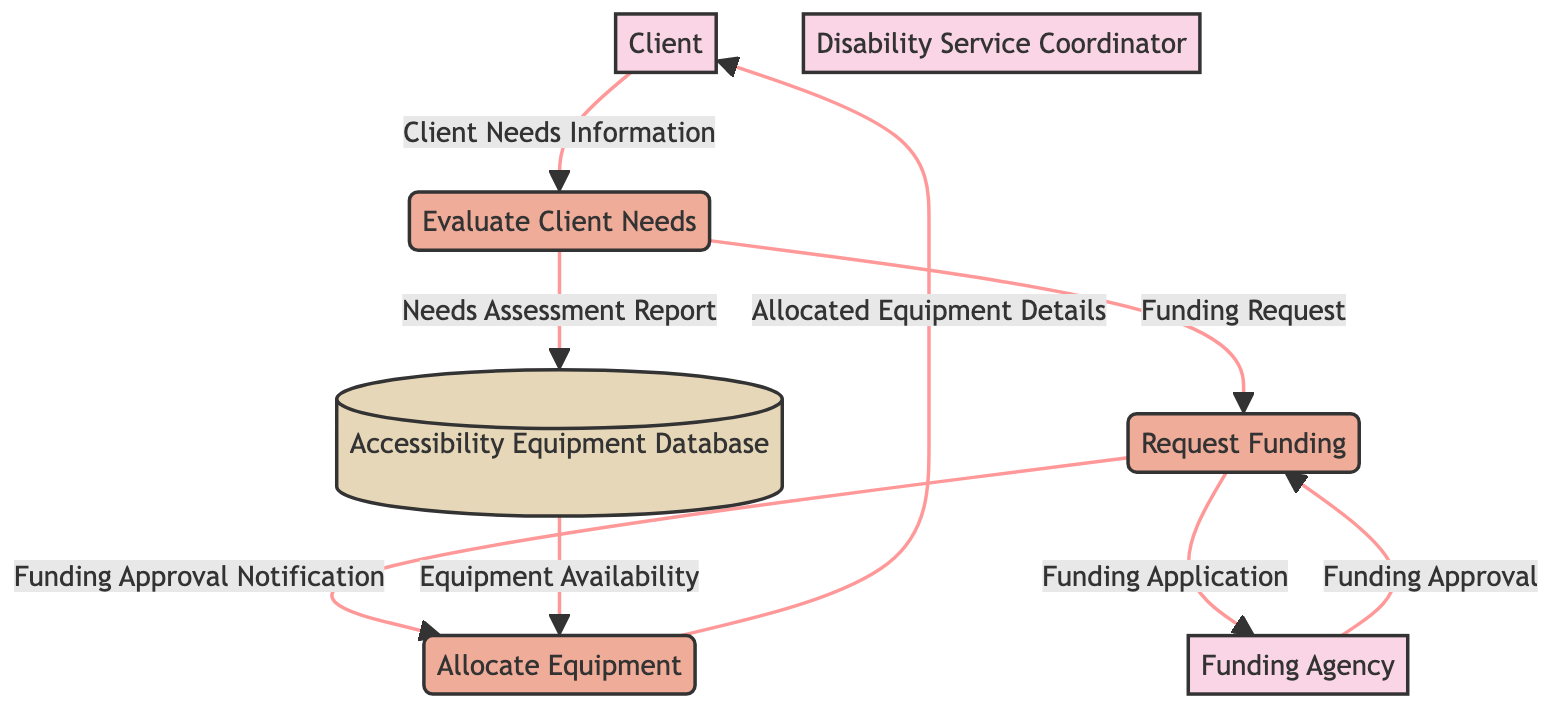What is the first process in the diagram? The first process listed in the diagram is "Evaluate Client Needs." This can be identified by looking for the first labeled box under the "Process" category.
Answer: Evaluate Client Needs How many external entities are there? There are four external entities shown in the diagram: "Client," "Disability Service Coordinator," "Funding Agency," and "Accessibility Equipment Database." By counting the boxes labeled as external entities, we reach this total.
Answer: 4 What data flow goes from the Client to the Evaluate Client Needs process? The data flow from the Client to the Evaluate Client Needs process is labeled "Client Needs Information." This can be identified by following the arrow from the Client node to the Evaluate Client Needs process in the diagram.
Answer: Client Needs Information Which process receives the "Funding Approval Notification"? The process that receives the "Funding Approval Notification" is "Allocate Equipment." This can be determined by examining the flow and the label that connects the Request Funding process to the Allocate Equipment process.
Answer: Allocate Equipment From which external entity does the Request Funding process obtain approval? The Request Funding process obtains approval from the "Funding Agency." This is clear as the arrow labeled "Funding Approval" flows from the Funding Agency back to the Request Funding process.
Answer: Funding Agency What type of data is represented by the Needs Assessment Report? The Needs Assessment Report is represented as a "Data Flow" that moves from the Evaluate Client Needs process to the Accessibility Equipment Database. The type is indicated by the relationship between the processes and the data store.
Answer: Data Flow What flow connects the Accessibility Equipment Database to the Allocate Equipment process? The flow connecting the Accessibility Equipment Database to the Allocate Equipment process is labeled "Equipment Availability." This connection shows the movement of data from the database to the equipment allocation process.
Answer: Equipment Availability How many processes are there in the diagram? There are three processes identified in the diagram: "Evaluate Client Needs," "Request Funding," and "Allocate Equipment." This total is confirmed by counting the number of labeled process boxes.
Answer: 3 What is sent from the Funding Agency to the Request Funding process? The Funding Agency sends a "Funding Approval" to the Request Funding process. This can be verified by following the data flow arrow leading to the process labeled as "Funding Approval."
Answer: Funding Approval Which process is last in the data flow? The last process in the data flow is "Allocate Equipment." This can be concluded by tracing the flow through the diagram to see that it leads to the final output going to the Client, represented by the "Allocated Equipment Details."
Answer: Allocate Equipment 